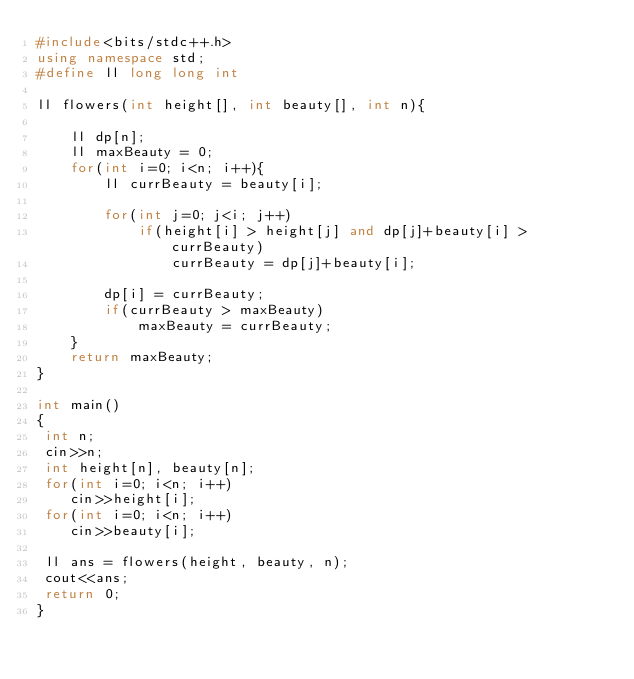Convert code to text. <code><loc_0><loc_0><loc_500><loc_500><_C++_>#include<bits/stdc++.h>
using namespace std;
#define ll long long int

ll flowers(int height[], int beauty[], int n){

    ll dp[n];
    ll maxBeauty = 0;
    for(int i=0; i<n; i++){
        ll currBeauty = beauty[i];
        
        for(int j=0; j<i; j++)
            if(height[i] > height[j] and dp[j]+beauty[i] > currBeauty)
                currBeauty = dp[j]+beauty[i];
                
        dp[i] = currBeauty;
        if(currBeauty > maxBeauty)
            maxBeauty = currBeauty;
    }
    return maxBeauty;
}

int main()
{
 int n;
 cin>>n;
 int height[n], beauty[n];
 for(int i=0; i<n; i++)
    cin>>height[i];
 for(int i=0; i<n; i++)
    cin>>beauty[i];

 ll ans = flowers(height, beauty, n);
 cout<<ans;
 return 0;
}
</code> 